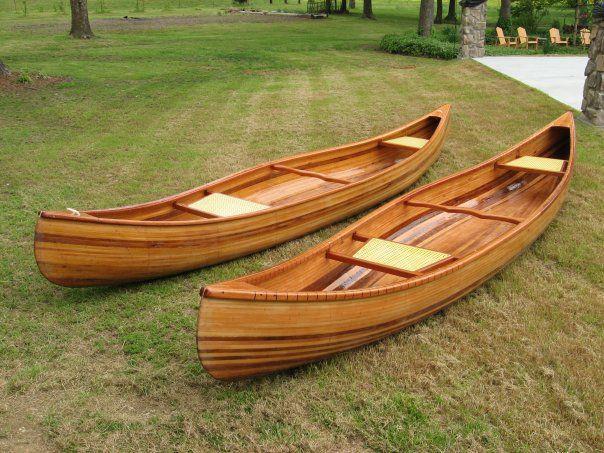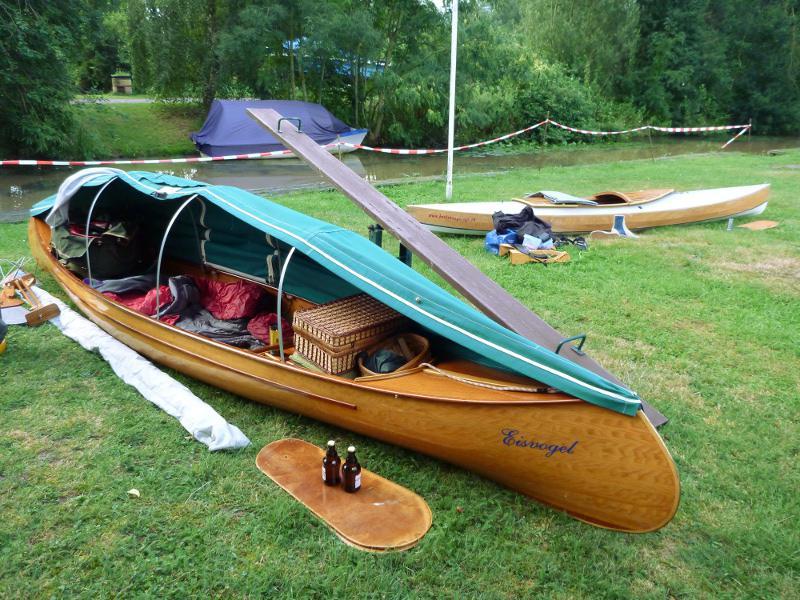The first image is the image on the left, the second image is the image on the right. For the images shown, is this caption "Each image shows a single prominent wooden boat, and the boats in the left and right images face the same general direction." true? Answer yes or no. No. The first image is the image on the left, the second image is the image on the right. Considering the images on both sides, is "There are more than two boats visible." valid? Answer yes or no. Yes. 